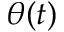Convert formula to latex. <formula><loc_0><loc_0><loc_500><loc_500>\theta ( t )</formula> 